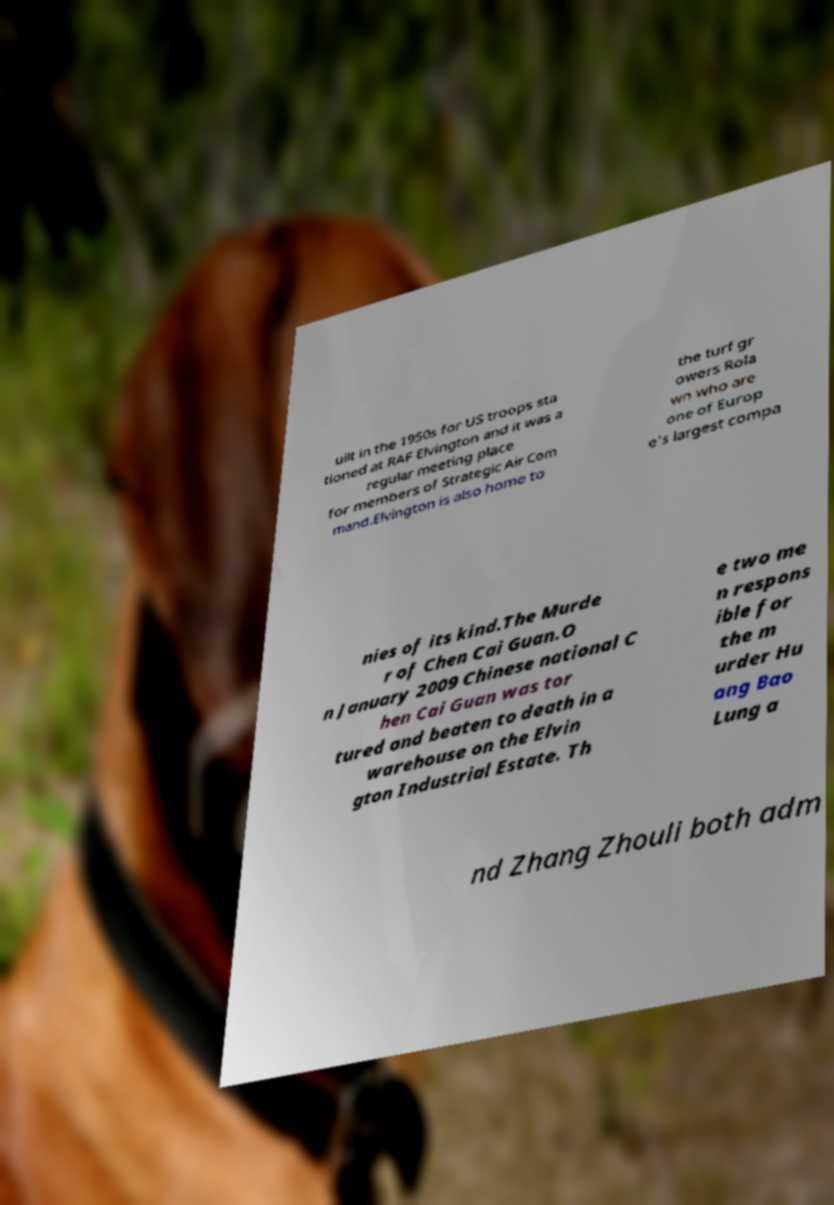I need the written content from this picture converted into text. Can you do that? uilt in the 1950s for US troops sta tioned at RAF Elvington and it was a regular meeting place for members of Strategic Air Com mand.Elvington is also home to the turf gr owers Rola wn who are one of Europ e's largest compa nies of its kind.The Murde r of Chen Cai Guan.O n January 2009 Chinese national C hen Cai Guan was tor tured and beaten to death in a warehouse on the Elvin gton Industrial Estate. Th e two me n respons ible for the m urder Hu ang Bao Lung a nd Zhang Zhouli both adm 